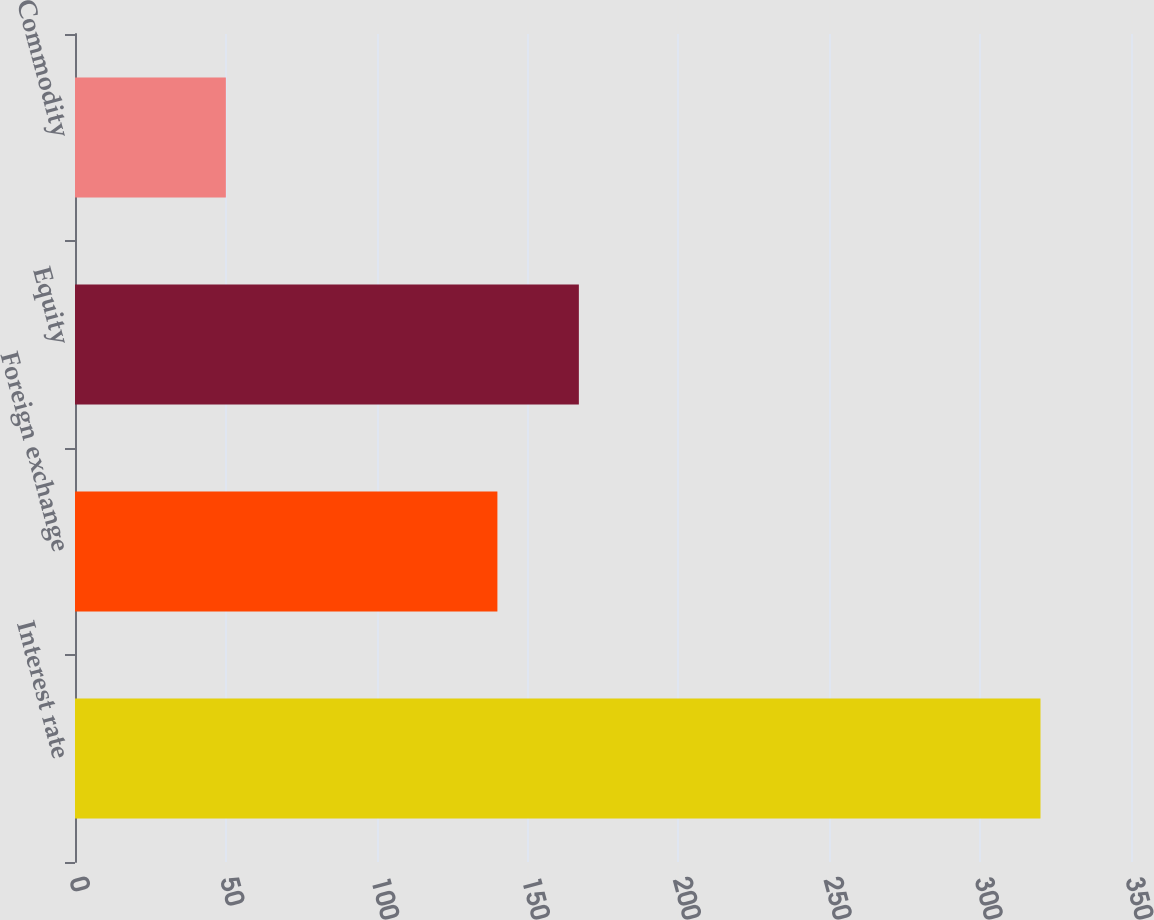Convert chart. <chart><loc_0><loc_0><loc_500><loc_500><bar_chart><fcel>Interest rate<fcel>Foreign exchange<fcel>Equity<fcel>Commodity<nl><fcel>320<fcel>140<fcel>167<fcel>50<nl></chart> 